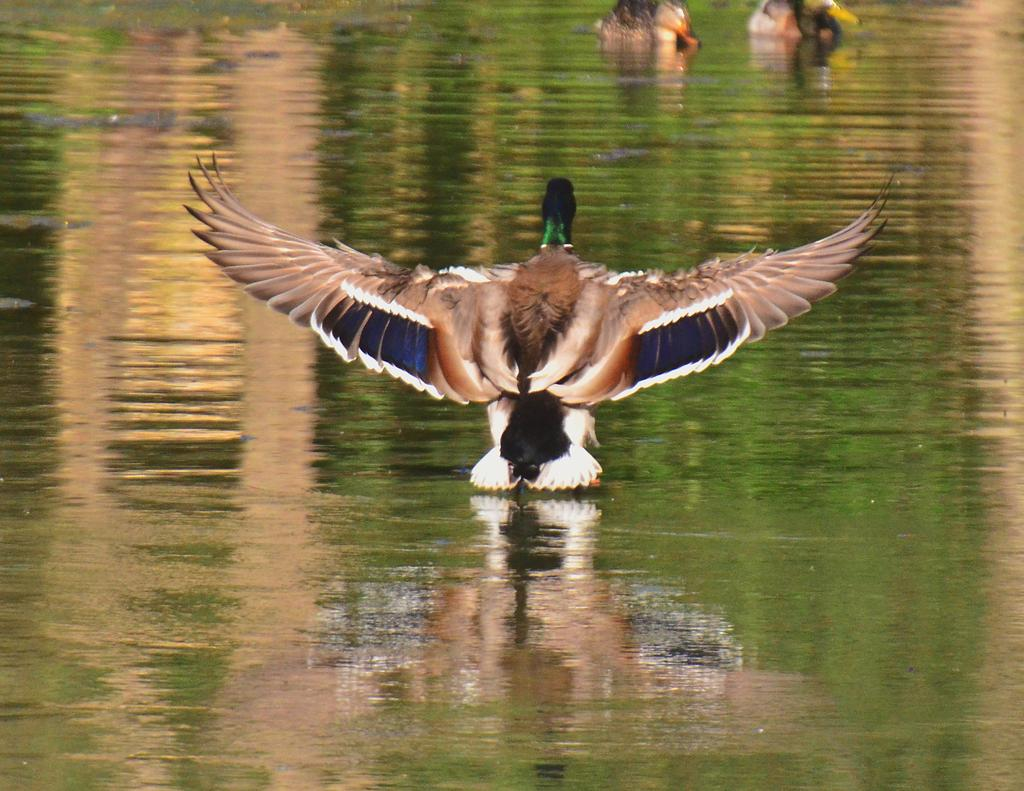What type of bird is in the center of the image? There is a mallard bird in the center of the image. Where is the mallard bird located in relation to the water? The mallard bird is near the water. How many birds are on the water in the top right of the image? There are two birds on the water in the top right of the image. What can be seen in the reflection in the water? There is an object visible in the reflection in the water. What is the name of the company that owns the nail in the image? There is no company or nail present in the image. 